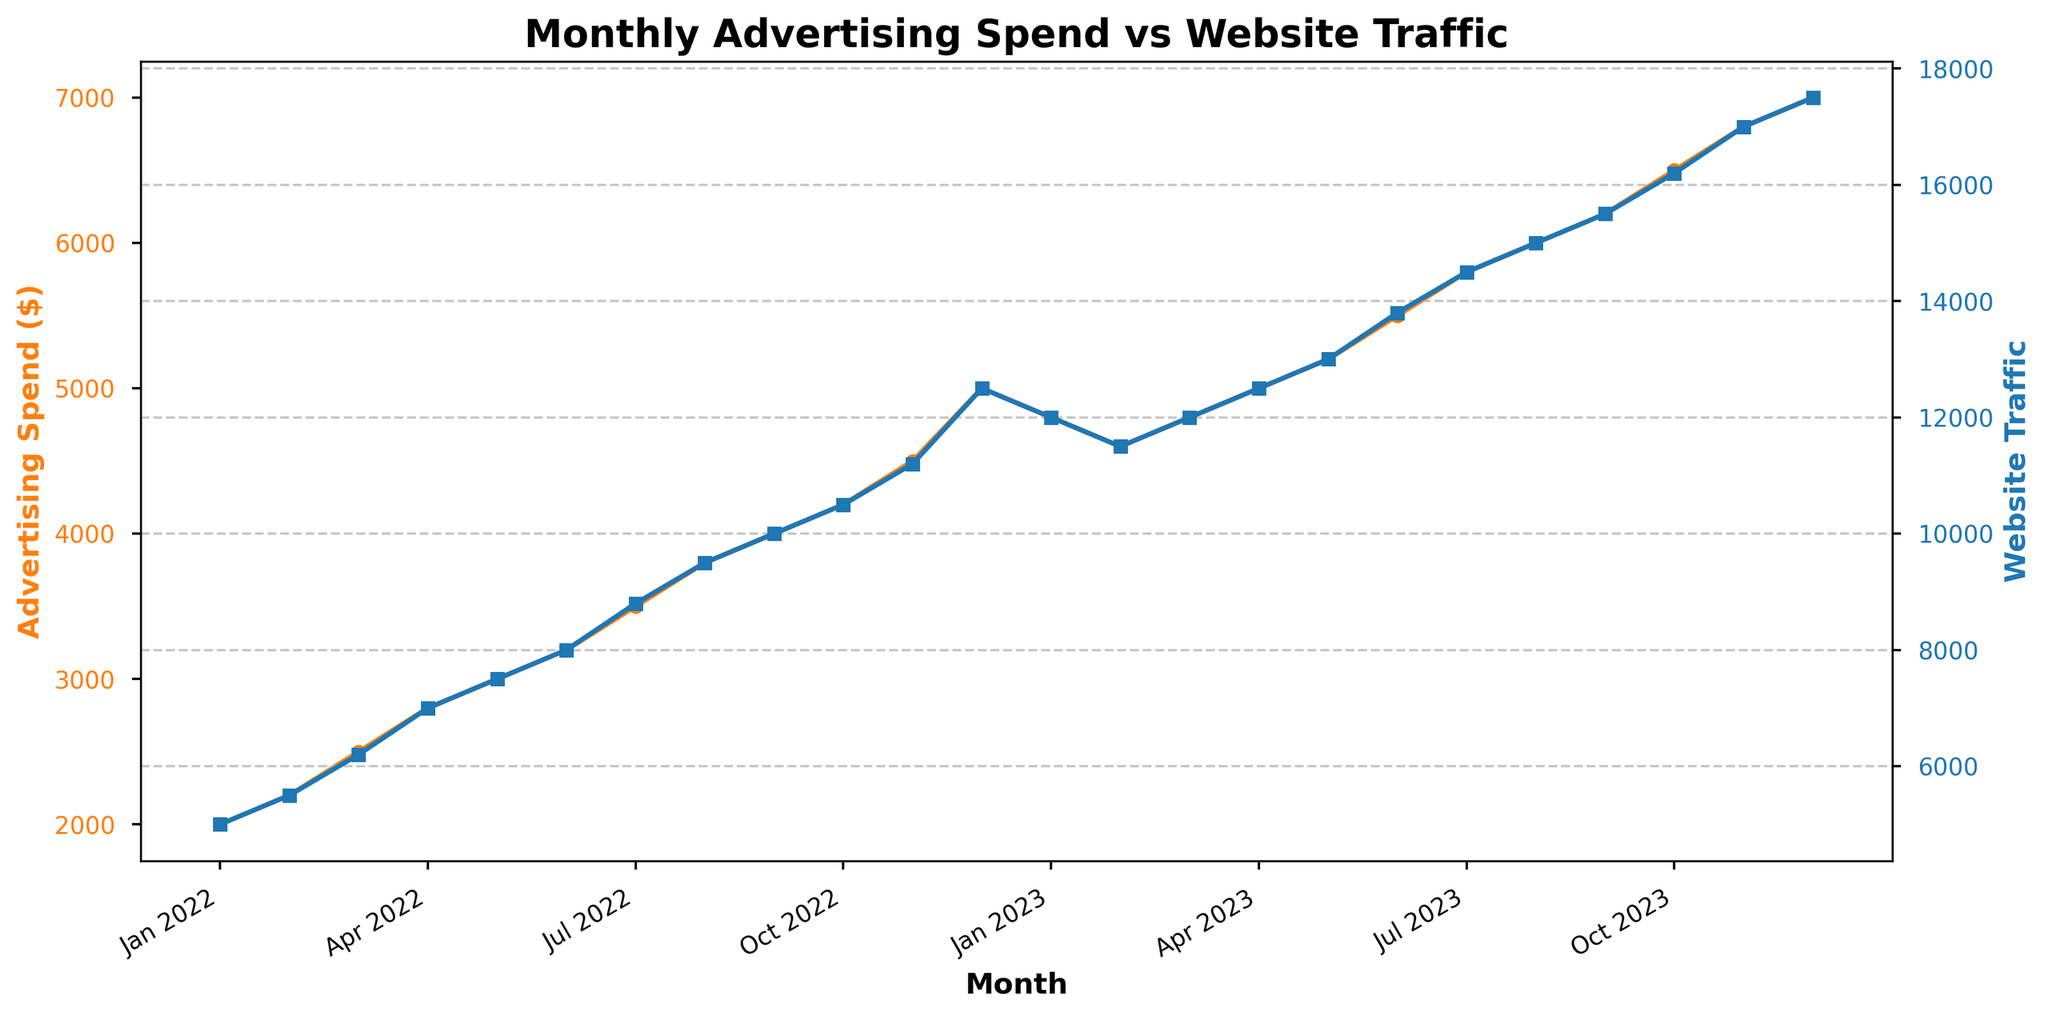What is the trend in advertising spend from Jan 2022 to Dec 2023? The advertising spend shows a general increasing trend from Jan 2022 ($2000) to Dec 2023 ($7000), with some minor fluctuations.
Answer: Increasing How does the website traffic in Jan 2023 compare to that in Jan 2022? In Jan 2022, the website traffic was 5000, while in Jan 2023, it was 12000. Therefore, the website traffic in Jan 2023 is more than twice that in Jan 2022.
Answer: More than twice What is the overall relationship between advertising spend and website traffic? As the advertising spend increases over the months from Jan 2022 to Dec 2023, the website traffic generally increases as well. The data shows a positive correlation.
Answer: Positive correlation Which month had the highest advertising spend, and what was the corresponding website traffic? The highest advertising spend was in Dec 2023, with an amount of $7000. The corresponding website traffic for that month was 17500.
Answer: December 2023, 17500 By how much did the advertising spend increase from Jun 2022 to Jun 2023? The advertising spend in Jun 2022 was $3200 and in Jun 2023 was $5500. The increase is $5500 - $3200 = $2300.
Answer: $2300 In which month did website traffic begin to consistently exceed 10000? Website traffic began to consistently exceed 10000 starting from Sep 2022, where it reached 10000.
Answer: September 2022 Compare the rate of increase in advertising spend and website traffic from Jan 2022 to Dec 2022. Advertising spend increased from $2000 in Jan 2022 to $5000 in Dec 2022, a rise of $3000. Website traffic increased from 5000 to 12500, a rise of 7500. The website traffic increased at a faster rate than advertising spend.
Answer: Website traffic increased faster What pattern can you observe in advertising spend and website traffic during the last quarter of each year? In the last quarter (Oct, Nov, Dec) of each year, both advertising spend and website traffic increase, showing a peak in Dec of both 2022 and 2023, indicating higher seasonal spending and traffic.
Answer: Increase during the last quarter If advertising spend in Nov 2023 was reduced to the level of Nov 2022, what would be the expected website traffic based on the trend? In Nov 2022, the advertising spend was $4500 and website traffic was 11200. If the spend in Nov 2023 was $4500, based on the observed correlation, the expected traffic would be close to 11200 rather than the actual 17000.
Answer: Close to 11200 What is the difference between the highest and lowest website traffic during the observed period? The highest website traffic was 17500 in Dec 2023, and the lowest was 5000 in Jan 2022. The difference is 17500 - 5000 = 12500.
Answer: 12500 